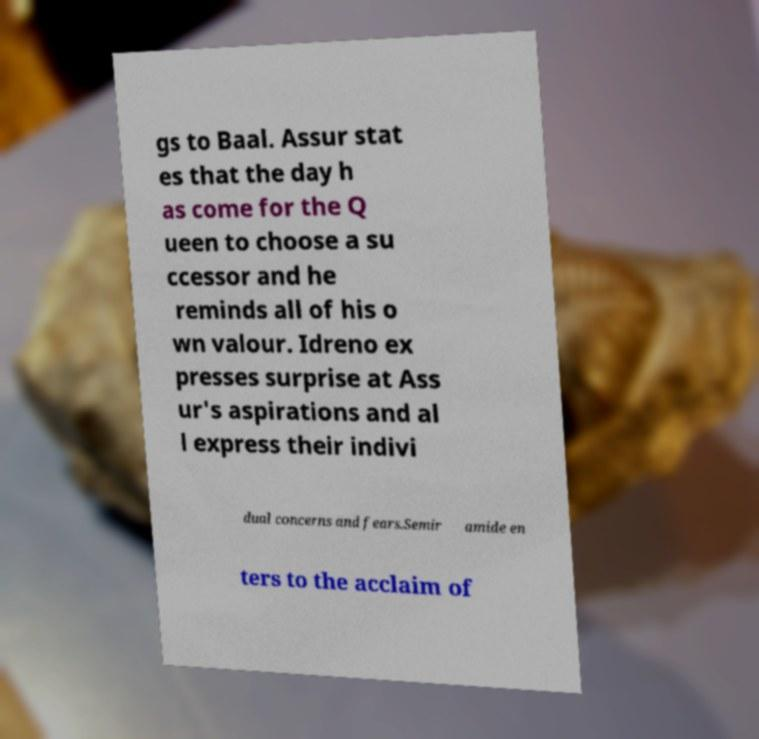There's text embedded in this image that I need extracted. Can you transcribe it verbatim? gs to Baal. Assur stat es that the day h as come for the Q ueen to choose a su ccessor and he reminds all of his o wn valour. Idreno ex presses surprise at Ass ur's aspirations and al l express their indivi dual concerns and fears.Semir amide en ters to the acclaim of 